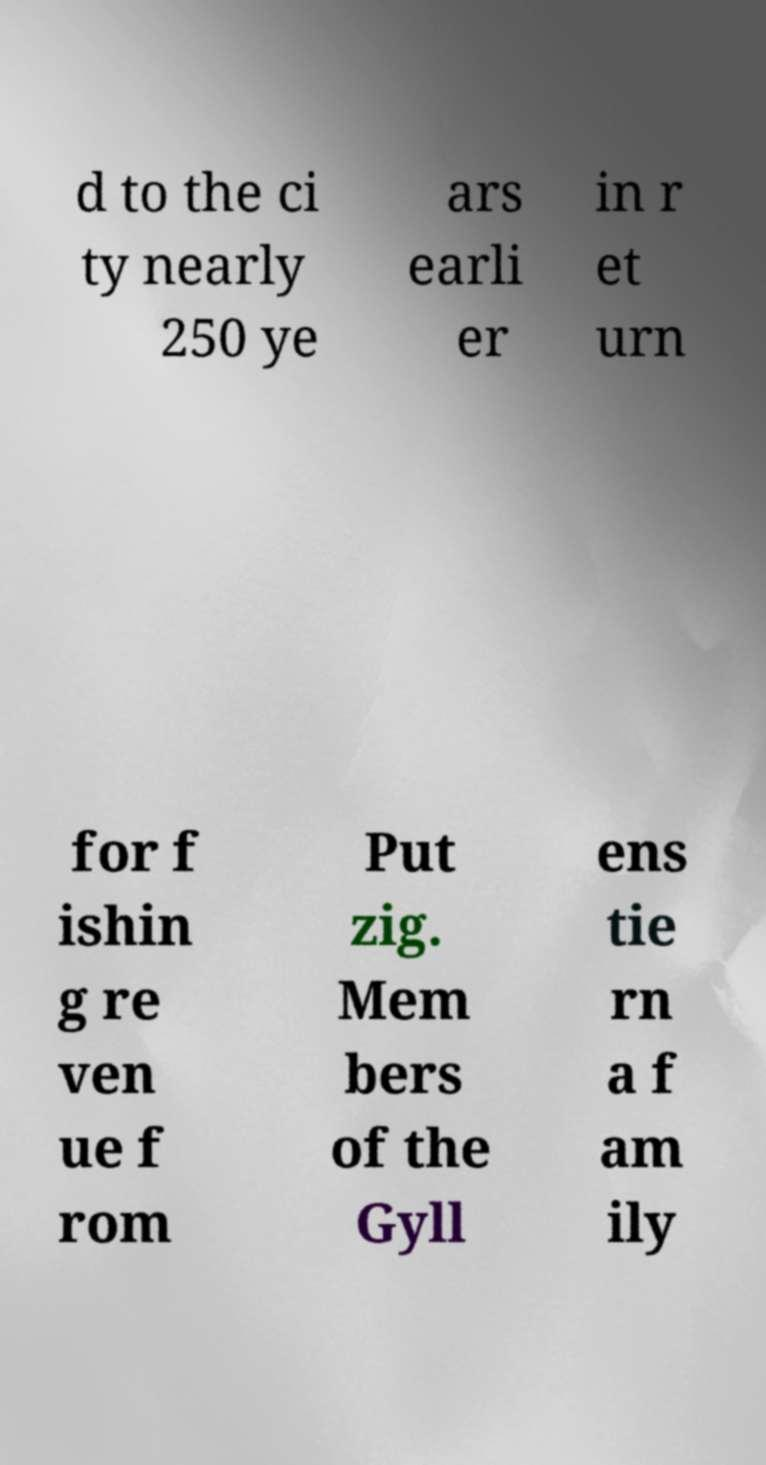What messages or text are displayed in this image? I need them in a readable, typed format. d to the ci ty nearly 250 ye ars earli er in r et urn for f ishin g re ven ue f rom Put zig. Mem bers of the Gyll ens tie rn a f am ily 